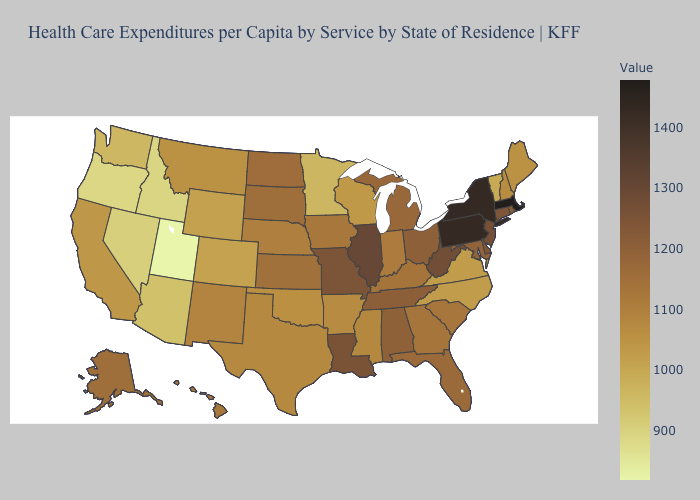Among the states that border Florida , which have the lowest value?
Concise answer only. Georgia. Among the states that border Ohio , which have the highest value?
Be succinct. Pennsylvania. Does Vermont have the lowest value in the USA?
Write a very short answer. No. Among the states that border New Jersey , which have the lowest value?
Short answer required. Delaware. Does Illinois have the highest value in the MidWest?
Answer briefly. Yes. Which states hav the highest value in the MidWest?
Short answer required. Illinois. 